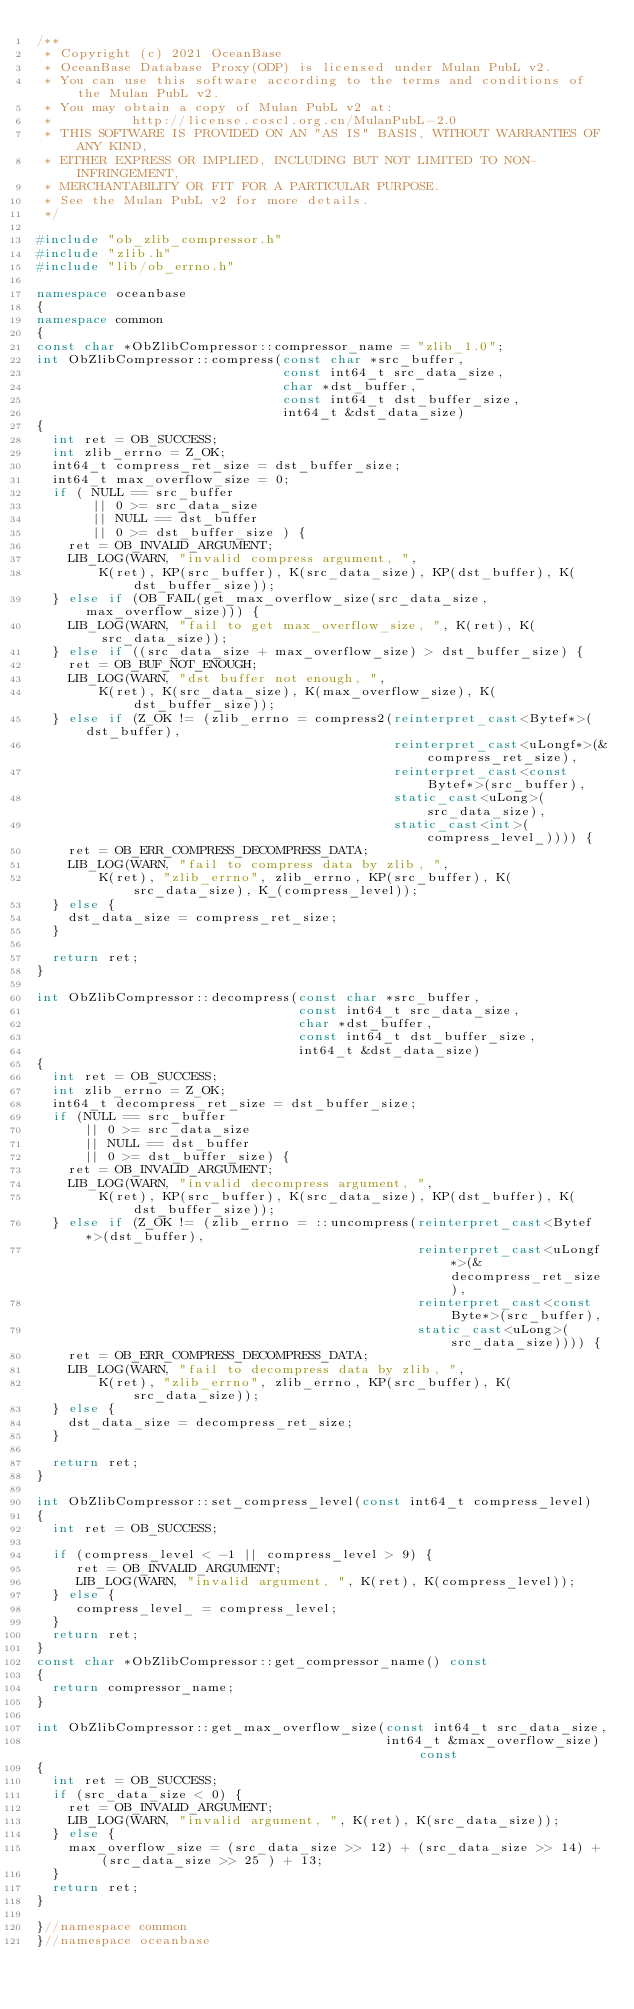Convert code to text. <code><loc_0><loc_0><loc_500><loc_500><_C++_>/**
 * Copyright (c) 2021 OceanBase
 * OceanBase Database Proxy(ODP) is licensed under Mulan PubL v2.
 * You can use this software according to the terms and conditions of the Mulan PubL v2.
 * You may obtain a copy of Mulan PubL v2 at:
 *          http://license.coscl.org.cn/MulanPubL-2.0
 * THIS SOFTWARE IS PROVIDED ON AN "AS IS" BASIS, WITHOUT WARRANTIES OF ANY KIND,
 * EITHER EXPRESS OR IMPLIED, INCLUDING BUT NOT LIMITED TO NON-INFRINGEMENT,
 * MERCHANTABILITY OR FIT FOR A PARTICULAR PURPOSE.
 * See the Mulan PubL v2 for more details.
 */

#include "ob_zlib_compressor.h"
#include "zlib.h"
#include "lib/ob_errno.h"

namespace oceanbase
{
namespace common
{
const char *ObZlibCompressor::compressor_name = "zlib_1.0";
int ObZlibCompressor::compress(const char *src_buffer,
                               const int64_t src_data_size,
                               char *dst_buffer,
                               const int64_t dst_buffer_size,
                               int64_t &dst_data_size)
{
  int ret = OB_SUCCESS;
  int zlib_errno = Z_OK;
  int64_t compress_ret_size = dst_buffer_size;
  int64_t max_overflow_size = 0;
  if ( NULL == src_buffer
       || 0 >= src_data_size
       || NULL == dst_buffer
       || 0 >= dst_buffer_size ) {
    ret = OB_INVALID_ARGUMENT;
    LIB_LOG(WARN, "invalid compress argument, ",
        K(ret), KP(src_buffer), K(src_data_size), KP(dst_buffer), K(dst_buffer_size));
  } else if (OB_FAIL(get_max_overflow_size(src_data_size, max_overflow_size))) {
    LIB_LOG(WARN, "fail to get max_overflow_size, ", K(ret), K(src_data_size));
  } else if ((src_data_size + max_overflow_size) > dst_buffer_size) {
    ret = OB_BUF_NOT_ENOUGH;
    LIB_LOG(WARN, "dst buffer not enough, ",
        K(ret), K(src_data_size), K(max_overflow_size), K(dst_buffer_size));
  } else if (Z_OK != (zlib_errno = compress2(reinterpret_cast<Bytef*>(dst_buffer),
					                                   reinterpret_cast<uLongf*>(&compress_ret_size),
					                                   reinterpret_cast<const Bytef*>(src_buffer),
					                                   static_cast<uLong>(src_data_size),
					                                   static_cast<int>(compress_level_)))) {
    ret = OB_ERR_COMPRESS_DECOMPRESS_DATA;
    LIB_LOG(WARN, "fail to compress data by zlib, ",
        K(ret), "zlib_errno", zlib_errno, KP(src_buffer), K(src_data_size), K_(compress_level));
  } else {
    dst_data_size = compress_ret_size;
  }

  return ret;
}

int ObZlibCompressor::decompress(const char *src_buffer,
			                           const int64_t src_data_size,
			                           char *dst_buffer,
			                           const int64_t dst_buffer_size,
			                           int64_t &dst_data_size)
{
  int ret = OB_SUCCESS;
  int zlib_errno = Z_OK;
  int64_t decompress_ret_size = dst_buffer_size;
  if (NULL == src_buffer
      || 0 >= src_data_size
      || NULL == dst_buffer
      || 0 >= dst_buffer_size) {
    ret = OB_INVALID_ARGUMENT;
    LIB_LOG(WARN, "invalid decompress argument, ",
        K(ret), KP(src_buffer), K(src_data_size), KP(dst_buffer), K(dst_buffer_size));
  } else if (Z_OK != (zlib_errno = ::uncompress(reinterpret_cast<Bytef*>(dst_buffer),
                                                reinterpret_cast<uLongf*>(&decompress_ret_size),
                                                reinterpret_cast<const Byte*>(src_buffer),
                                                static_cast<uLong>(src_data_size)))) {
    ret = OB_ERR_COMPRESS_DECOMPRESS_DATA;
    LIB_LOG(WARN, "fail to decompress data by zlib, ",
        K(ret), "zlib_errno", zlib_errno, KP(src_buffer), K(src_data_size));
  } else {
    dst_data_size = decompress_ret_size;
  }

  return ret;
}

int ObZlibCompressor::set_compress_level(const int64_t compress_level)
{
  int ret = OB_SUCCESS;

  if (compress_level < -1 || compress_level > 9) {
     ret = OB_INVALID_ARGUMENT;
     LIB_LOG(WARN, "invalid argument, ", K(ret), K(compress_level));
  } else {
     compress_level_ = compress_level;
  }
  return ret;
}
const char *ObZlibCompressor::get_compressor_name() const
{
  return compressor_name;
}

int ObZlibCompressor::get_max_overflow_size(const int64_t src_data_size,
                                            int64_t &max_overflow_size) const
{
  int ret = OB_SUCCESS;
  if (src_data_size < 0) {
    ret = OB_INVALID_ARGUMENT;
    LIB_LOG(WARN, "invalid argument, ", K(ret), K(src_data_size));
  } else {
    max_overflow_size = (src_data_size >> 12) + (src_data_size >> 14) + (src_data_size >> 25 ) + 13;
  }
  return ret;
}

}//namespace common
}//namespace oceanbase
</code> 